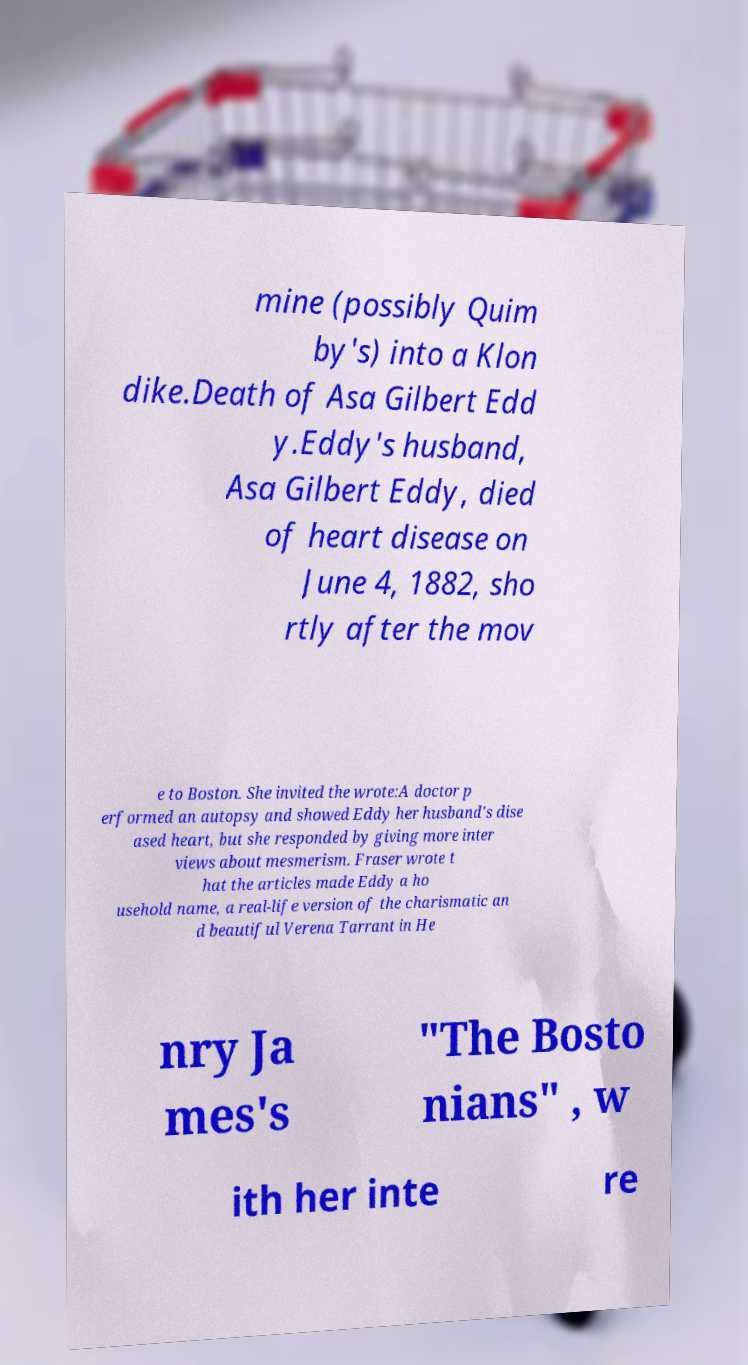Please identify and transcribe the text found in this image. mine (possibly Quim by's) into a Klon dike.Death of Asa Gilbert Edd y.Eddy's husband, Asa Gilbert Eddy, died of heart disease on June 4, 1882, sho rtly after the mov e to Boston. She invited the wrote:A doctor p erformed an autopsy and showed Eddy her husband's dise ased heart, but she responded by giving more inter views about mesmerism. Fraser wrote t hat the articles made Eddy a ho usehold name, a real-life version of the charismatic an d beautiful Verena Tarrant in He nry Ja mes's "The Bosto nians" , w ith her inte re 